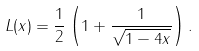Convert formula to latex. <formula><loc_0><loc_0><loc_500><loc_500>L ( x ) = \frac { 1 } { 2 } \left ( 1 + \frac { 1 } { \sqrt { 1 - 4 x } } \right ) .</formula> 